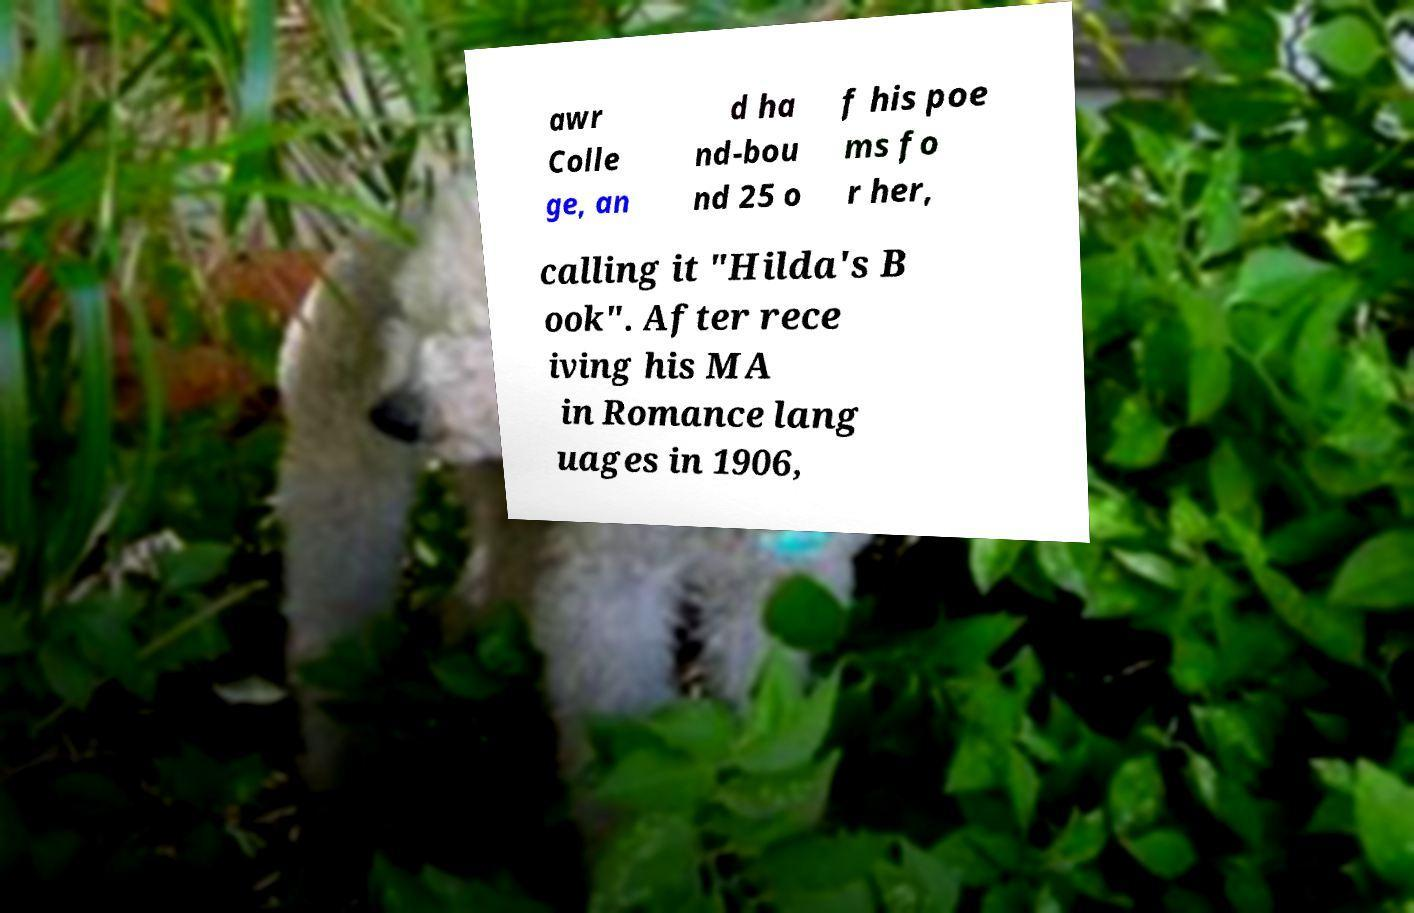Could you assist in decoding the text presented in this image and type it out clearly? awr Colle ge, an d ha nd-bou nd 25 o f his poe ms fo r her, calling it "Hilda's B ook". After rece iving his MA in Romance lang uages in 1906, 